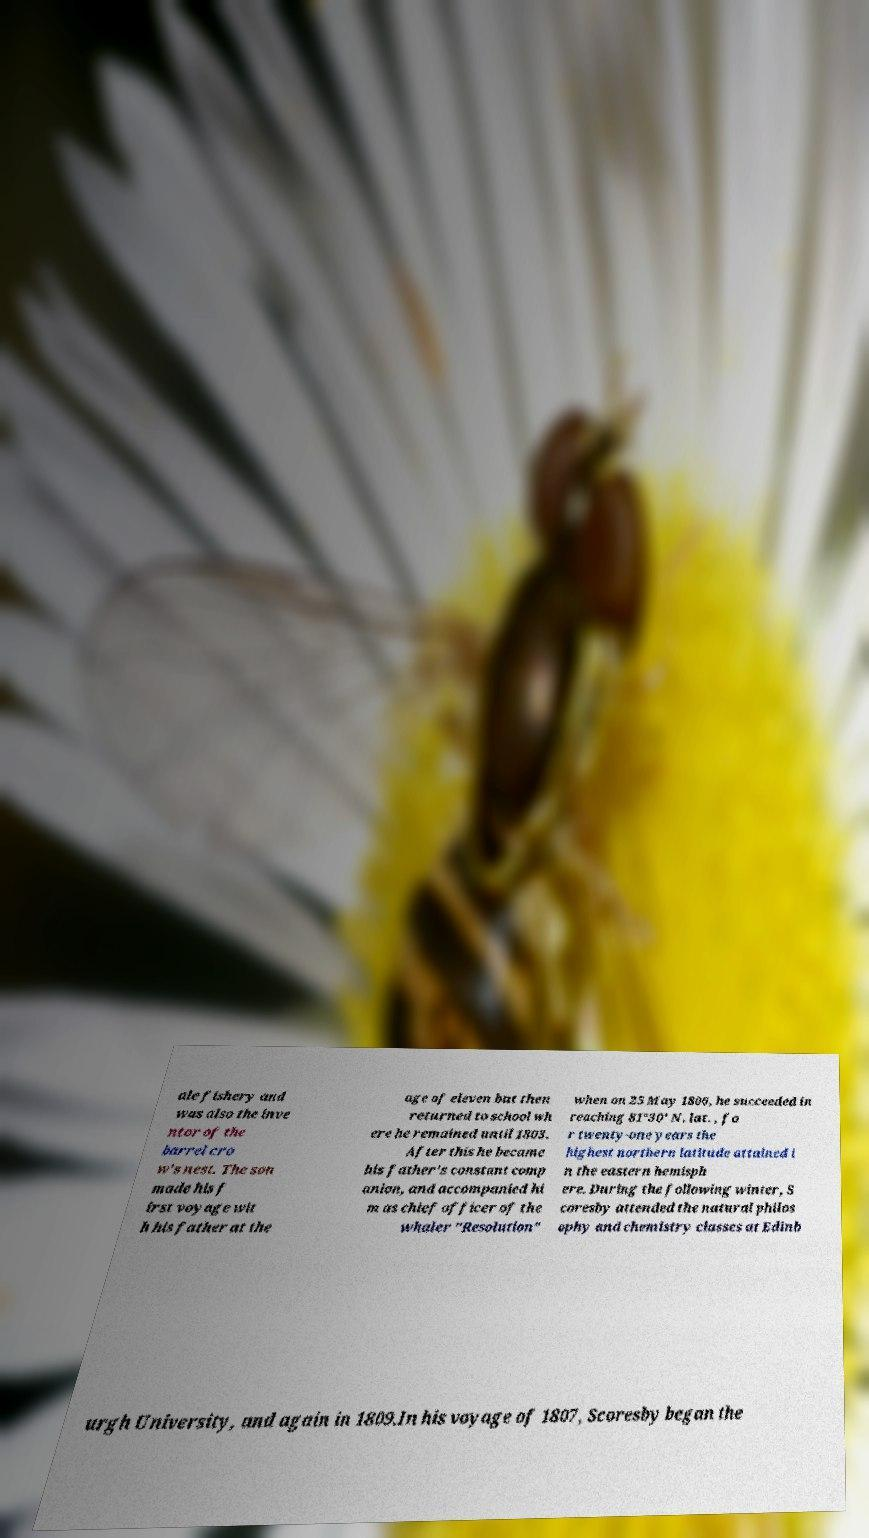Can you read and provide the text displayed in the image?This photo seems to have some interesting text. Can you extract and type it out for me? ale fishery and was also the inve ntor of the barrel cro w's nest. The son made his f irst voyage wit h his father at the age of eleven but then returned to school wh ere he remained until 1803. After this he became his father's constant comp anion, and accompanied hi m as chief officer of the whaler "Resolution" when on 25 May 1806, he succeeded in reaching 81°30' N. lat. , fo r twenty-one years the highest northern latitude attained i n the eastern hemisph ere. During the following winter, S coresby attended the natural philos ophy and chemistry classes at Edinb urgh University, and again in 1809.In his voyage of 1807, Scoresby began the 